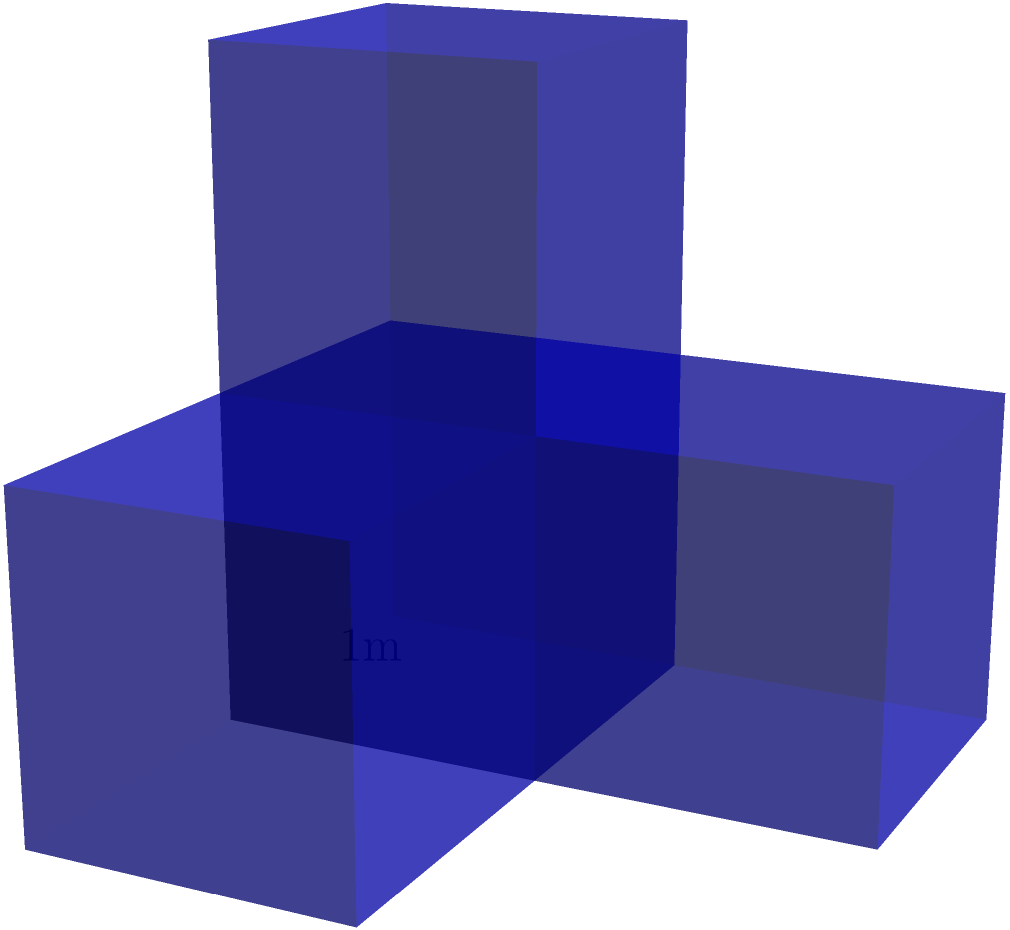You are designing a sculptural installation inspired by Juanita Lecaros's geometric abstractions. The installation consists of four interconnected unit cubes arranged as shown in the diagram. If each cube has a side length of 1 meter, what is the total surface area of the installation in square meters? Let's approach this step-by-step:

1) First, let's count the exposed faces of each cube:
   - Cube 1 (bottom left): 4 faces exposed
   - Cube 2 (top left): 4 faces exposed
   - Cube 3 (bottom right): 4 faces exposed
   - Cube 4 (top right): 5 faces exposed

2) Total number of exposed faces: 4 + 4 + 4 + 5 = 17

3) Each face is a square with side length 1 meter, so its area is:
   $A = 1^2 = 1$ square meter

4) Therefore, the total surface area is:
   $SA = 17 * 1 = 17$ square meters

This sculptural arrangement creates an interesting play of volumes and negative spaces, reminiscent of Lecaros's exploration of geometric forms in her artworks.
Answer: 17 square meters 